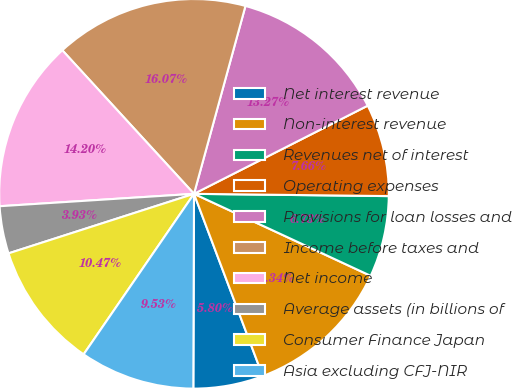<chart> <loc_0><loc_0><loc_500><loc_500><pie_chart><fcel>Net interest revenue<fcel>Non-interest revenue<fcel>Revenues net of interest<fcel>Operating expenses<fcel>Provisions for loan losses and<fcel>Income before taxes and<fcel>Net income<fcel>Average assets (in billions of<fcel>Consumer Finance Japan<fcel>Asia excluding CFJ-NIR<nl><fcel>5.8%<fcel>12.34%<fcel>6.73%<fcel>7.66%<fcel>13.27%<fcel>16.07%<fcel>14.2%<fcel>3.93%<fcel>10.47%<fcel>9.53%<nl></chart> 